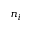Convert formula to latex. <formula><loc_0><loc_0><loc_500><loc_500>n _ { i }</formula> 